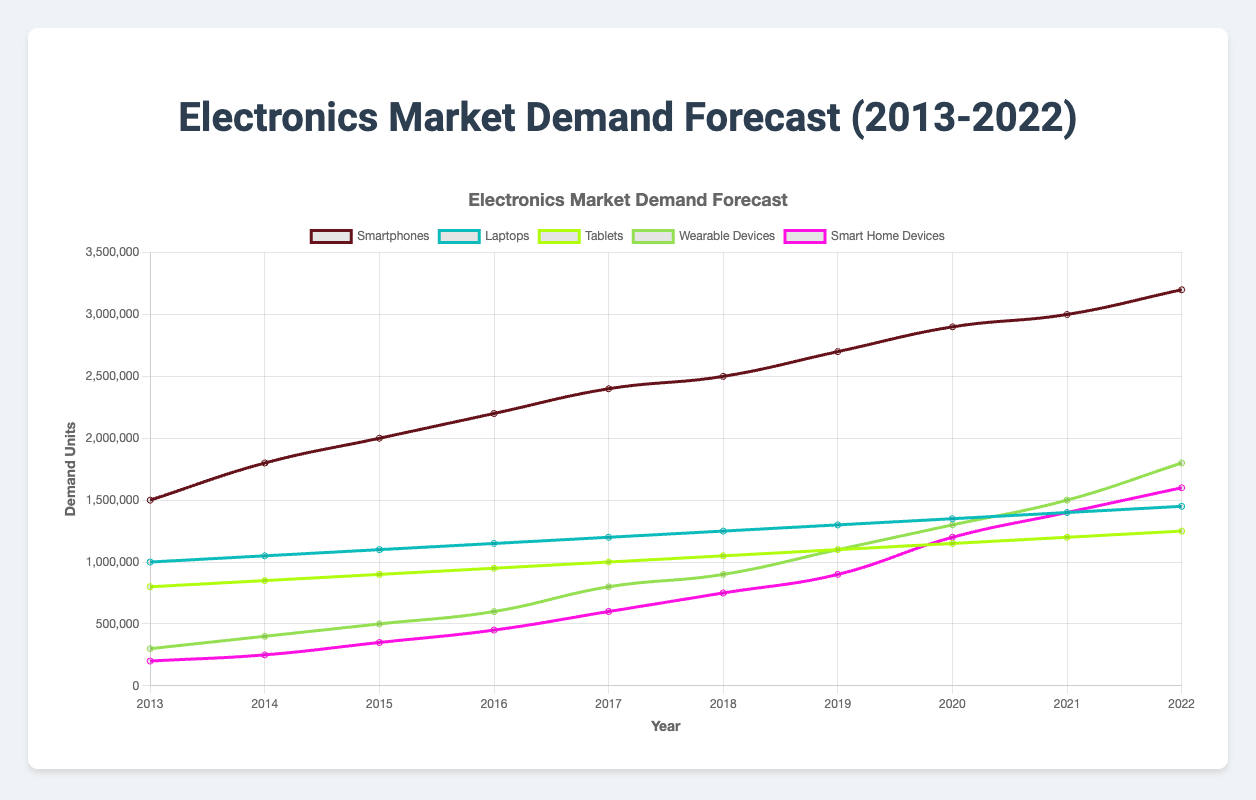What was the overall trend for smartphone demand from 2013 to 2022? The overall trend for smartphone demand shows a consistent increase each year. Starting at 1,500,000 units in 2013 and rising to 3,200,000 units in 2022, the demand grew steadily reflecting a growing market for smartphones over the decade.
Answer: Consistent increase Which product type experienced the most significant demand growth in absolute units from 2013 to 2022? To find this, look at the difference in demand units between 2013 and 2022 for each product type. For smartphones, the demand increased by 1,700,000 units. Laptops saw an increase of 450,000 units. Tablets had a demand growth of 450,000 units. Wearable devices grew by 1,500,000 units. Smart home devices increased by 1,400,000 units. The largest increase was for smartphones (1,700,000 units).
Answer: Smartphones Among the product types, which had the highest demand in 2022? By comparing the demand units for 2022 across all product types, we see that smartphones had the highest demand in 2022 with 3,200,000 units, followed by laptops with 1,450,000 units, tablets with 1,250,000 units, wearable devices with 1,800,000 units, and smart home devices with 1,600,000 units.
Answer: Smartphones Between 2015 and 2020, which product type had the most considerable percentage increase in demand? Calculate the percentage increase for each product type between 2015 and 2020. For smartphones, the increase was ((2900000 - 2000000) / 2000000) * 100% = 45%. For laptops, it was ((1350000 - 1100000) / 1100000) * 100% = 22.73%. For tablets, it was ((1150000 - 900000) / 900000) * 100% = 27.78%. For wearable devices, it was ((1300000 - 500000) / 500000) * 100% = 160%. For smart home devices, it was ((1200000 - 350000) / 350000) * 100% = 242.86%. Smart home devices had the most considerable increase.
Answer: Smart home devices What is the average annual demand for laptops between 2013 and 2022? Sum the annual demand for laptops from 2013 to 2022 and then divide by the number of years. (1000000 + 1050000 + 1100000 + 1150000 + 1200000 + 1250000 + 1300000 + 1350000 + 1400000 + 1450000) / 10 years = 12250000 / 10 = 1225000 units.
Answer: 1225000 units How does the demand for wearable devices in 2022 compare to 2013? Wearable devices had a demand of 300000 units in 2013 and 1800000 units in 2022. To compare: 1800000 - 300000 = 1500000 units increase, which is a significant growth. In percentage, this can be calculated as ((1800000 - 300000) / 300000) * 100% = 500%.
Answer: Demand increased by 1500000 units or 500% Which years saw the sharpest increase in demand for smart home devices? Analyzing the year-to-year growth, the biggest increase happened between 2016 (450000 units) and 2017 (600000 units) with an increase of 150000 units. Another significant increase was between 2019 (900000 units) and 2020 (1200000 units) with an increase of 300000 units.
Answer: 2019 to 2020 How does the demand trend for tablets compare to laptops over the decade? Both tablets and laptops show a steady increase in demand from 2013 to 2022. Tablets started at 800,000 units and ended at 1,250,000 units, while laptops started at 1,000,000 units and ended at 1,450,000 units. Laptops generally had higher demand but both products exhibit a similar steady growth pattern.
Answer: Steady increase, laptops generally higher 